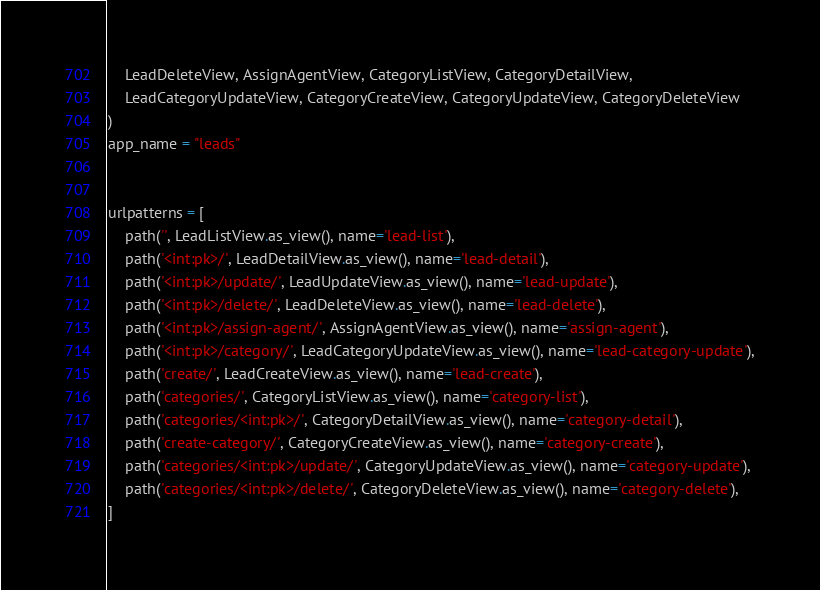<code> <loc_0><loc_0><loc_500><loc_500><_Python_>    LeadDeleteView, AssignAgentView, CategoryListView, CategoryDetailView,
    LeadCategoryUpdateView, CategoryCreateView, CategoryUpdateView, CategoryDeleteView
)
app_name = "leads"


urlpatterns = [
    path('', LeadListView.as_view(), name='lead-list'),
    path('<int:pk>/', LeadDetailView.as_view(), name='lead-detail'),
    path('<int:pk>/update/', LeadUpdateView.as_view(), name='lead-update'),
    path('<int:pk>/delete/', LeadDeleteView.as_view(), name='lead-delete'),
    path('<int:pk>/assign-agent/', AssignAgentView.as_view(), name='assign-agent'),
    path('<int:pk>/category/', LeadCategoryUpdateView.as_view(), name='lead-category-update'),
    path('create/', LeadCreateView.as_view(), name='lead-create'),
    path('categories/', CategoryListView.as_view(), name='category-list'),
    path('categories/<int:pk>/', CategoryDetailView.as_view(), name='category-detail'),
    path('create-category/', CategoryCreateView.as_view(), name='category-create'),
    path('categories/<int:pk>/update/', CategoryUpdateView.as_view(), name='category-update'),
    path('categories/<int:pk>/delete/', CategoryDeleteView.as_view(), name='category-delete'),
]</code> 